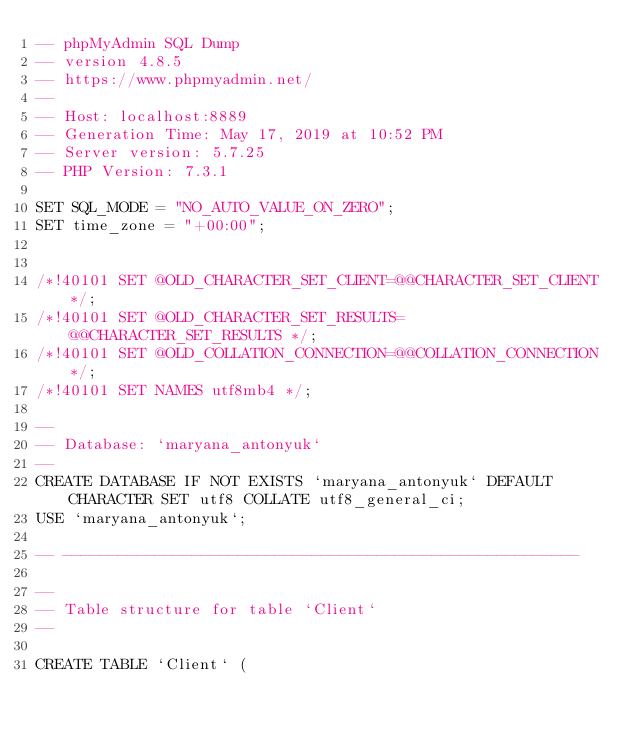<code> <loc_0><loc_0><loc_500><loc_500><_SQL_>-- phpMyAdmin SQL Dump
-- version 4.8.5
-- https://www.phpmyadmin.net/
--
-- Host: localhost:8889
-- Generation Time: May 17, 2019 at 10:52 PM
-- Server version: 5.7.25
-- PHP Version: 7.3.1

SET SQL_MODE = "NO_AUTO_VALUE_ON_ZERO";
SET time_zone = "+00:00";


/*!40101 SET @OLD_CHARACTER_SET_CLIENT=@@CHARACTER_SET_CLIENT */;
/*!40101 SET @OLD_CHARACTER_SET_RESULTS=@@CHARACTER_SET_RESULTS */;
/*!40101 SET @OLD_COLLATION_CONNECTION=@@COLLATION_CONNECTION */;
/*!40101 SET NAMES utf8mb4 */;

--
-- Database: `maryana_antonyuk`
--
CREATE DATABASE IF NOT EXISTS `maryana_antonyuk` DEFAULT CHARACTER SET utf8 COLLATE utf8_general_ci;
USE `maryana_antonyuk`;

-- --------------------------------------------------------

--
-- Table structure for table `Client`
--

CREATE TABLE `Client` (</code> 